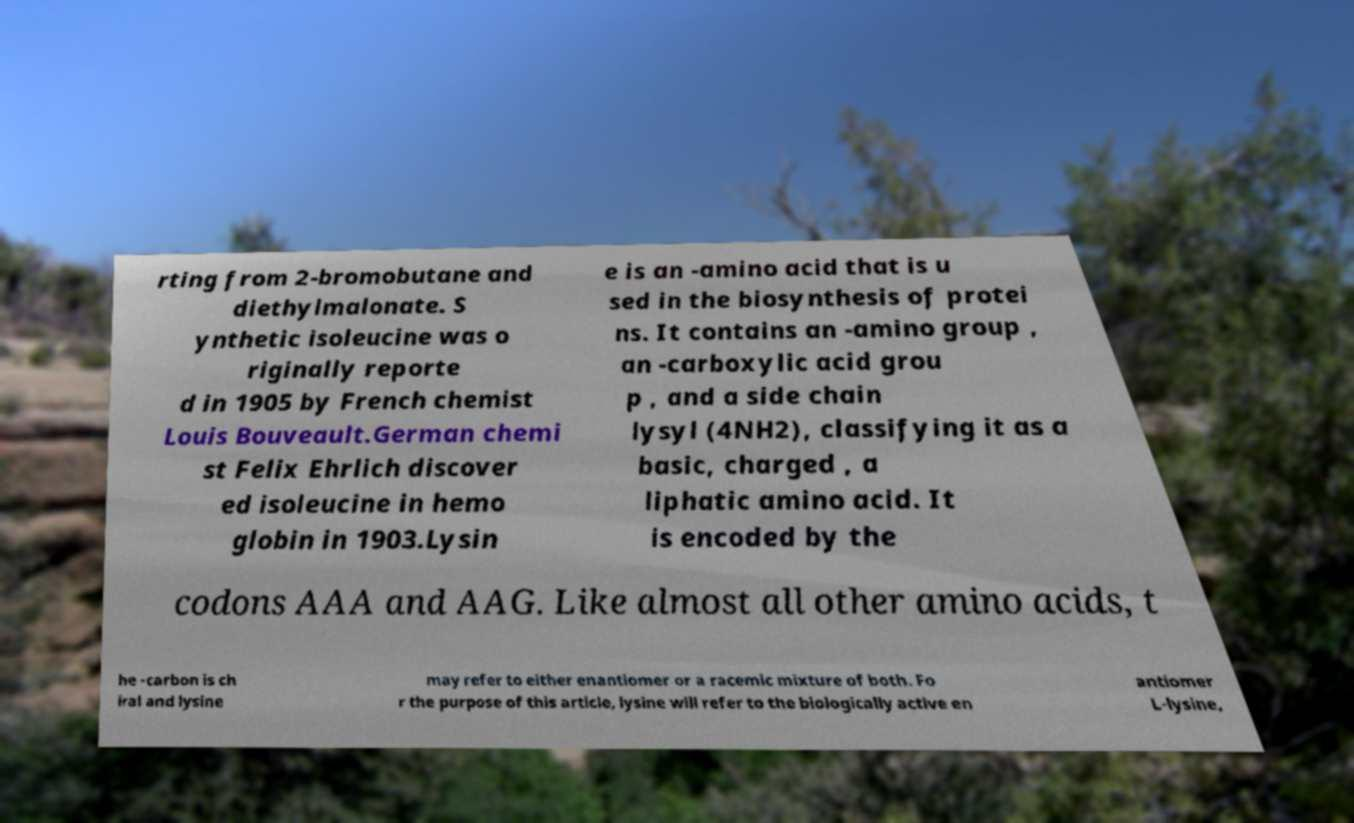Please read and relay the text visible in this image. What does it say? rting from 2-bromobutane and diethylmalonate. S ynthetic isoleucine was o riginally reporte d in 1905 by French chemist Louis Bouveault.German chemi st Felix Ehrlich discover ed isoleucine in hemo globin in 1903.Lysin e is an -amino acid that is u sed in the biosynthesis of protei ns. It contains an -amino group , an -carboxylic acid grou p , and a side chain lysyl (4NH2), classifying it as a basic, charged , a liphatic amino acid. It is encoded by the codons AAA and AAG. Like almost all other amino acids, t he -carbon is ch iral and lysine may refer to either enantiomer or a racemic mixture of both. Fo r the purpose of this article, lysine will refer to the biologically active en antiomer L-lysine, 